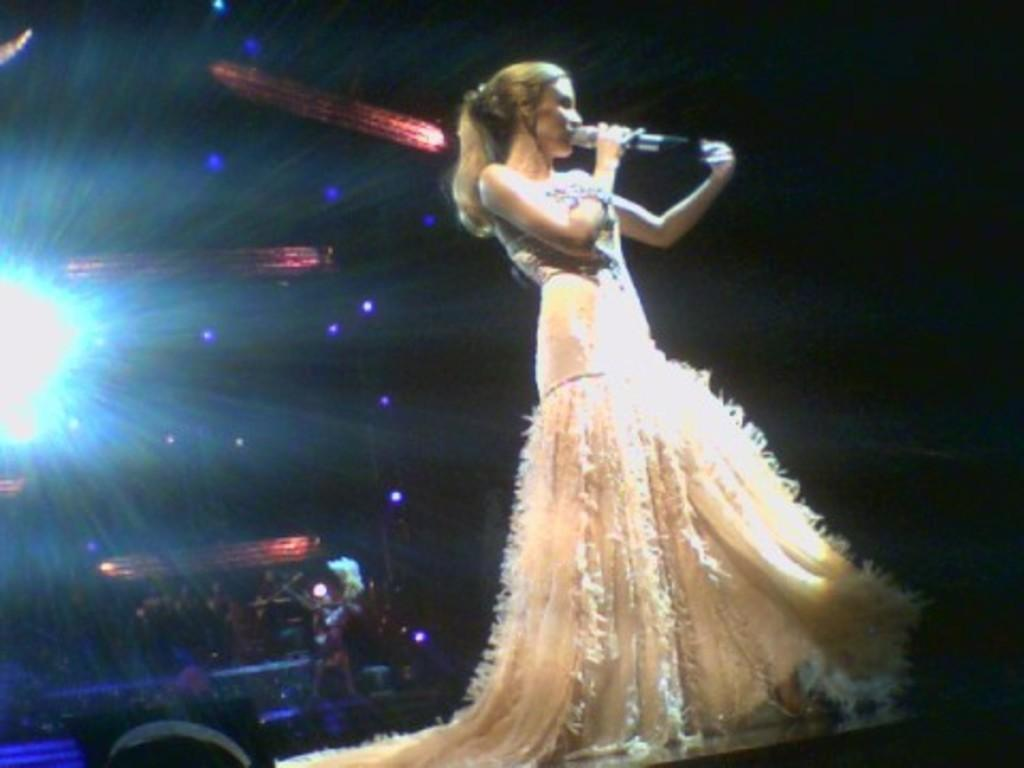What is the main subject of the image? The main subject of the image is a woman. What is the woman doing in the image? The woman is standing in the image. What is the woman wearing? The woman is wearing clothes and a bracelet. What object is the woman holding in her hand? The woman is holding a microphone in her hand. What can be seen in terms of lighting in the image? There is light visible in the image. How would you describe the background of the image? The background of the image is dark. What type of paste is being used by the woman in the image? There is no paste visible in the image, and the woman is not using any paste. What impulse is the woman reacting to in the image? There is no indication of any impulse or reaction in the image. 